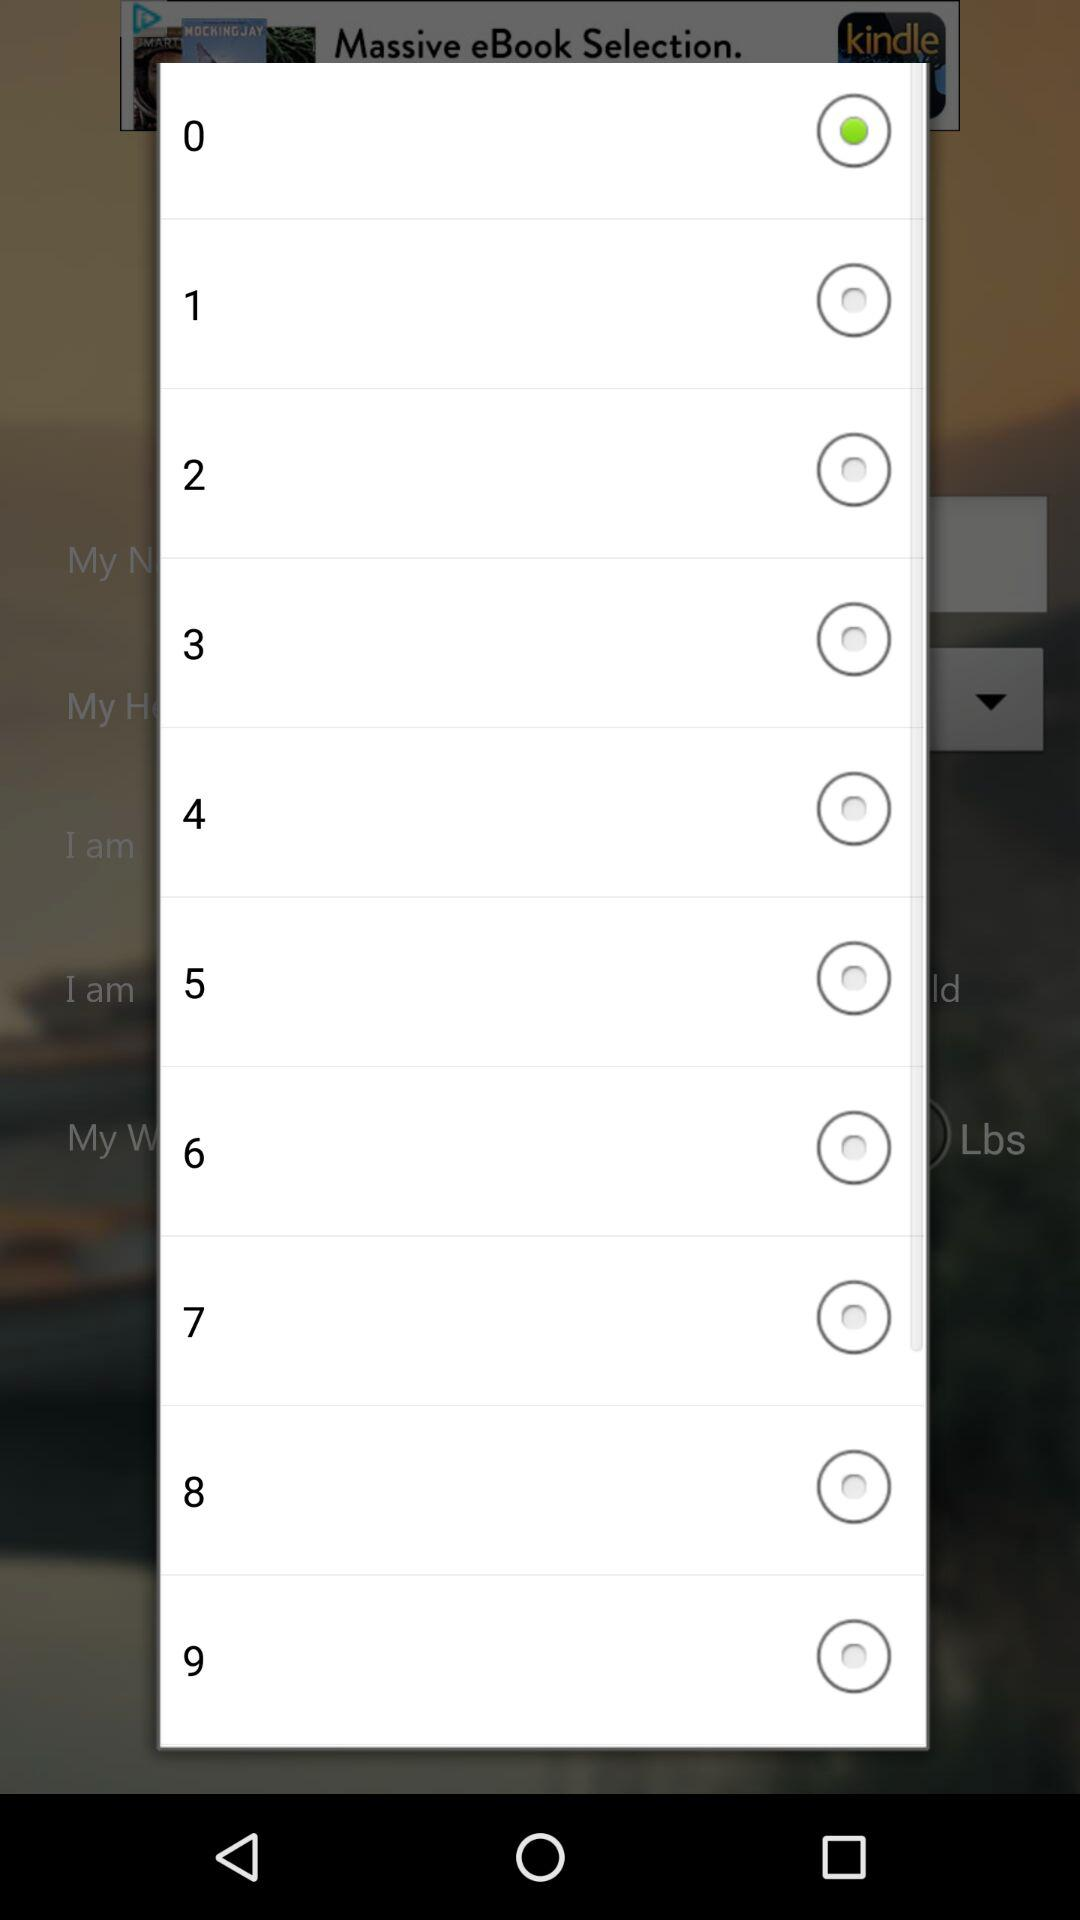What are the options available? The options available are 0,1, 2, 3, 4, 5, 6, 7, 8 and 9. 